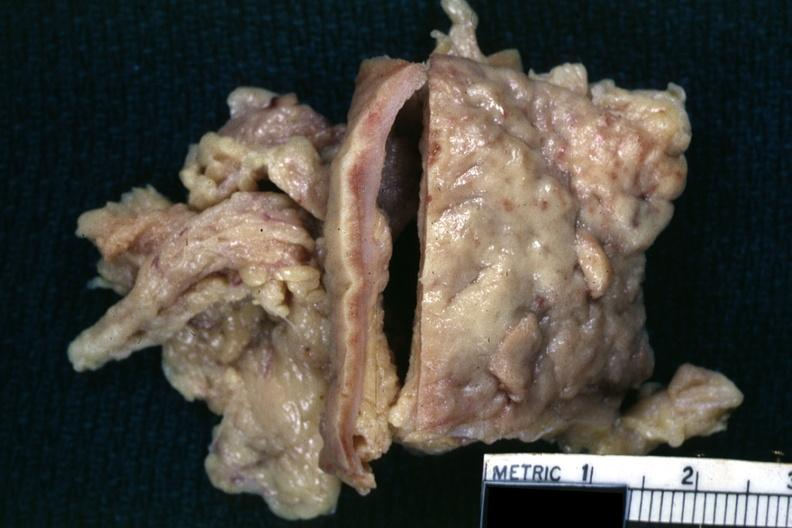what does this image show?
Answer the question using a single word or phrase. Fixed tissue 